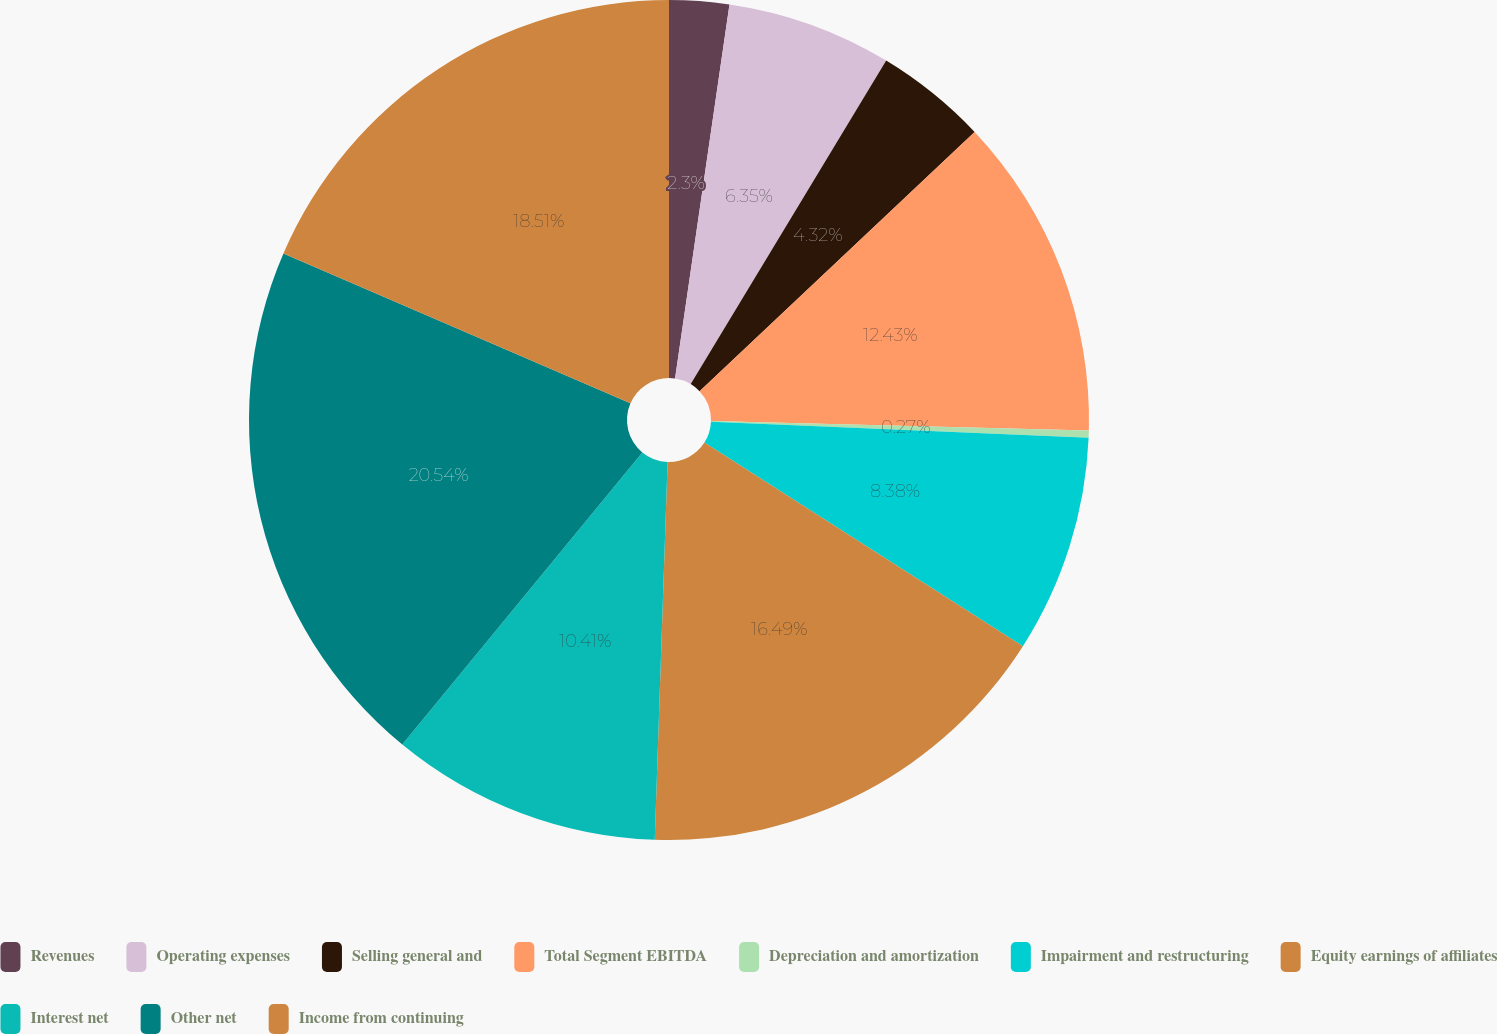Convert chart to OTSL. <chart><loc_0><loc_0><loc_500><loc_500><pie_chart><fcel>Revenues<fcel>Operating expenses<fcel>Selling general and<fcel>Total Segment EBITDA<fcel>Depreciation and amortization<fcel>Impairment and restructuring<fcel>Equity earnings of affiliates<fcel>Interest net<fcel>Other net<fcel>Income from continuing<nl><fcel>2.3%<fcel>6.35%<fcel>4.32%<fcel>12.43%<fcel>0.27%<fcel>8.38%<fcel>16.49%<fcel>10.41%<fcel>20.54%<fcel>18.51%<nl></chart> 